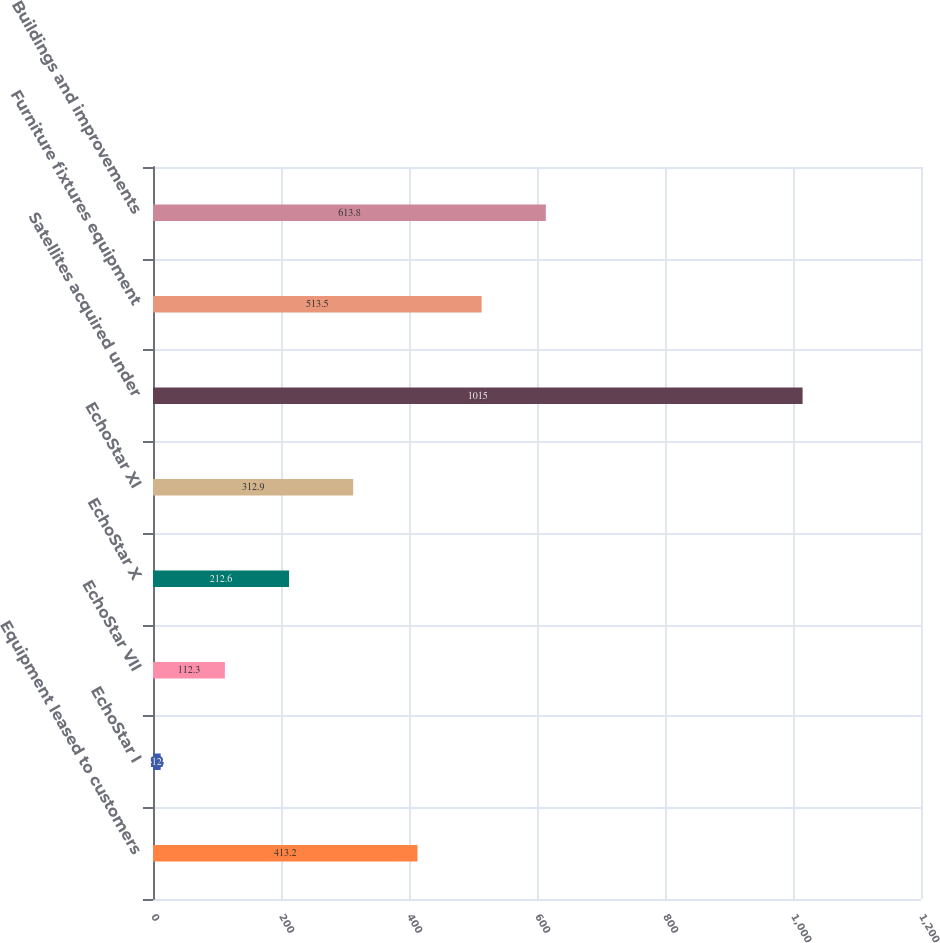Convert chart to OTSL. <chart><loc_0><loc_0><loc_500><loc_500><bar_chart><fcel>Equipment leased to customers<fcel>EchoStar I<fcel>EchoStar VII<fcel>EchoStar X<fcel>EchoStar XI<fcel>Satellites acquired under<fcel>Furniture fixtures equipment<fcel>Buildings and improvements<nl><fcel>413.2<fcel>12<fcel>112.3<fcel>212.6<fcel>312.9<fcel>1015<fcel>513.5<fcel>613.8<nl></chart> 